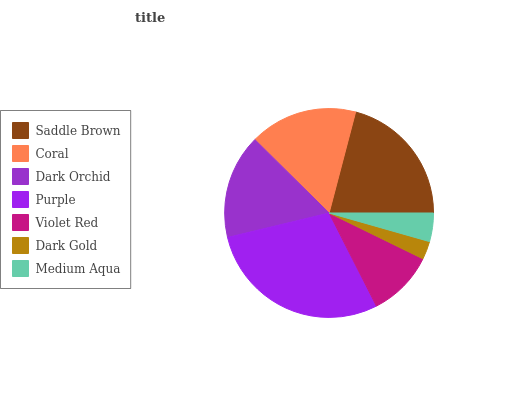Is Dark Gold the minimum?
Answer yes or no. Yes. Is Purple the maximum?
Answer yes or no. Yes. Is Coral the minimum?
Answer yes or no. No. Is Coral the maximum?
Answer yes or no. No. Is Saddle Brown greater than Coral?
Answer yes or no. Yes. Is Coral less than Saddle Brown?
Answer yes or no. Yes. Is Coral greater than Saddle Brown?
Answer yes or no. No. Is Saddle Brown less than Coral?
Answer yes or no. No. Is Dark Orchid the high median?
Answer yes or no. Yes. Is Dark Orchid the low median?
Answer yes or no. Yes. Is Dark Gold the high median?
Answer yes or no. No. Is Saddle Brown the low median?
Answer yes or no. No. 